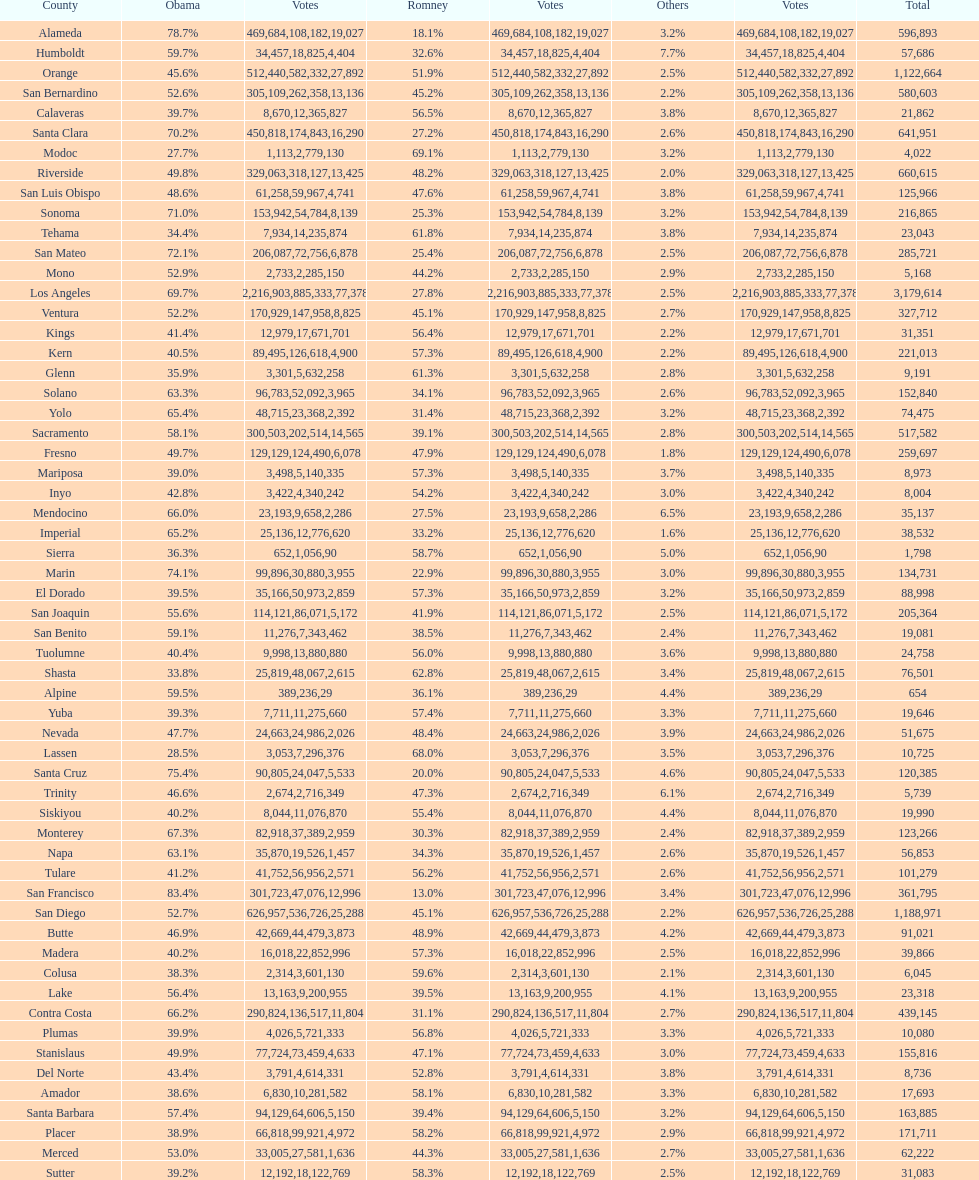Which count had the least number of votes for obama? Modoc. 